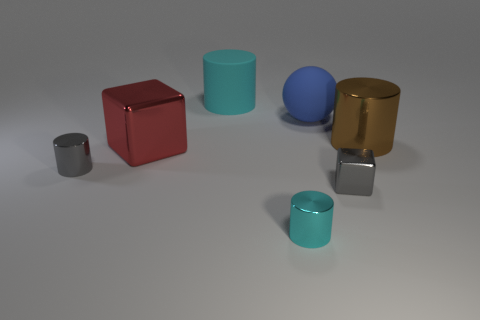Add 2 big red objects. How many objects exist? 9 Subtract all spheres. How many objects are left? 6 Subtract all tiny blue blocks. Subtract all large blue objects. How many objects are left? 6 Add 1 gray objects. How many gray objects are left? 3 Add 3 big blue rubber things. How many big blue rubber things exist? 4 Subtract 1 red blocks. How many objects are left? 6 